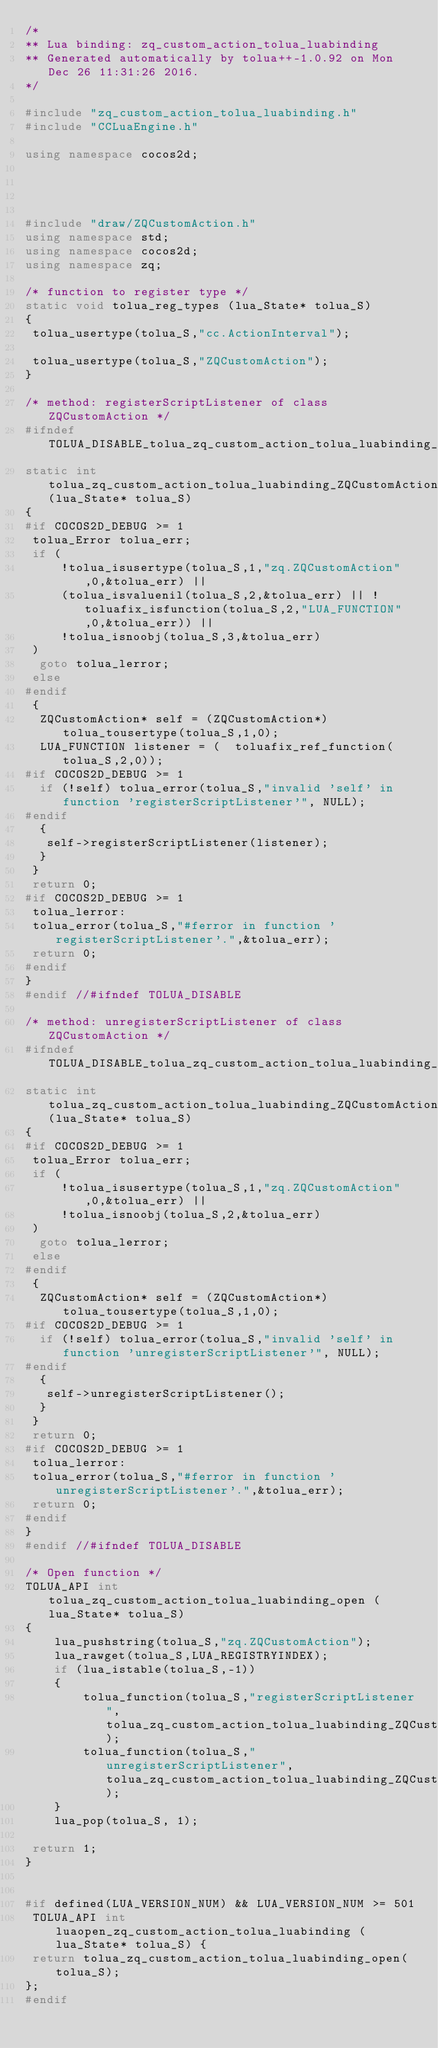Convert code to text. <code><loc_0><loc_0><loc_500><loc_500><_C++_>/*
** Lua binding: zq_custom_action_tolua_luabinding
** Generated automatically by tolua++-1.0.92 on Mon Dec 26 11:31:26 2016.
*/

#include "zq_custom_action_tolua_luabinding.h"
#include "CCLuaEngine.h"

using namespace cocos2d;




#include "draw/ZQCustomAction.h"
using namespace std;
using namespace cocos2d;
using namespace zq;

/* function to register type */
static void tolua_reg_types (lua_State* tolua_S)
{
 tolua_usertype(tolua_S,"cc.ActionInterval");
 
 tolua_usertype(tolua_S,"ZQCustomAction");
}

/* method: registerScriptListener of class  ZQCustomAction */
#ifndef TOLUA_DISABLE_tolua_zq_custom_action_tolua_luabinding_ZQCustomAction_registerScriptListener00
static int tolua_zq_custom_action_tolua_luabinding_ZQCustomAction_registerScriptListener00(lua_State* tolua_S)
{
#if COCOS2D_DEBUG >= 1
 tolua_Error tolua_err;
 if (
     !tolua_isusertype(tolua_S,1,"zq.ZQCustomAction",0,&tolua_err) ||
     (tolua_isvaluenil(tolua_S,2,&tolua_err) || !toluafix_isfunction(tolua_S,2,"LUA_FUNCTION",0,&tolua_err)) ||
     !tolua_isnoobj(tolua_S,3,&tolua_err)
 )
  goto tolua_lerror;
 else
#endif
 {
  ZQCustomAction* self = (ZQCustomAction*)  tolua_tousertype(tolua_S,1,0);
  LUA_FUNCTION listener = (  toluafix_ref_function(tolua_S,2,0));
#if COCOS2D_DEBUG >= 1
  if (!self) tolua_error(tolua_S,"invalid 'self' in function 'registerScriptListener'", NULL);
#endif
  {
   self->registerScriptListener(listener);
  }
 }
 return 0;
#if COCOS2D_DEBUG >= 1
 tolua_lerror:
 tolua_error(tolua_S,"#ferror in function 'registerScriptListener'.",&tolua_err);
 return 0;
#endif
}
#endif //#ifndef TOLUA_DISABLE

/* method: unregisterScriptListener of class  ZQCustomAction */
#ifndef TOLUA_DISABLE_tolua_zq_custom_action_tolua_luabinding_ZQCustomAction_unregisterScriptListener00
static int tolua_zq_custom_action_tolua_luabinding_ZQCustomAction_unregisterScriptListener00(lua_State* tolua_S)
{
#if COCOS2D_DEBUG >= 1
 tolua_Error tolua_err;
 if (
     !tolua_isusertype(tolua_S,1,"zq.ZQCustomAction",0,&tolua_err) ||
     !tolua_isnoobj(tolua_S,2,&tolua_err)
 )
  goto tolua_lerror;
 else
#endif
 {
  ZQCustomAction* self = (ZQCustomAction*)  tolua_tousertype(tolua_S,1,0);
#if COCOS2D_DEBUG >= 1
  if (!self) tolua_error(tolua_S,"invalid 'self' in function 'unregisterScriptListener'", NULL);
#endif
  {
   self->unregisterScriptListener();
  }
 }
 return 0;
#if COCOS2D_DEBUG >= 1
 tolua_lerror:
 tolua_error(tolua_S,"#ferror in function 'unregisterScriptListener'.",&tolua_err);
 return 0;
#endif
}
#endif //#ifndef TOLUA_DISABLE

/* Open function */
TOLUA_API int tolua_zq_custom_action_tolua_luabinding_open (lua_State* tolua_S)
{
    lua_pushstring(tolua_S,"zq.ZQCustomAction");
    lua_rawget(tolua_S,LUA_REGISTRYINDEX);
    if (lua_istable(tolua_S,-1))
    {
        tolua_function(tolua_S,"registerScriptListener",tolua_zq_custom_action_tolua_luabinding_ZQCustomAction_registerScriptListener00);
        tolua_function(tolua_S,"unregisterScriptListener",tolua_zq_custom_action_tolua_luabinding_ZQCustomAction_unregisterScriptListener00);
    }
    lua_pop(tolua_S, 1);
    
 return 1;
}


#if defined(LUA_VERSION_NUM) && LUA_VERSION_NUM >= 501
 TOLUA_API int luaopen_zq_custom_action_tolua_luabinding (lua_State* tolua_S) {
 return tolua_zq_custom_action_tolua_luabinding_open(tolua_S);
};
#endif

</code> 